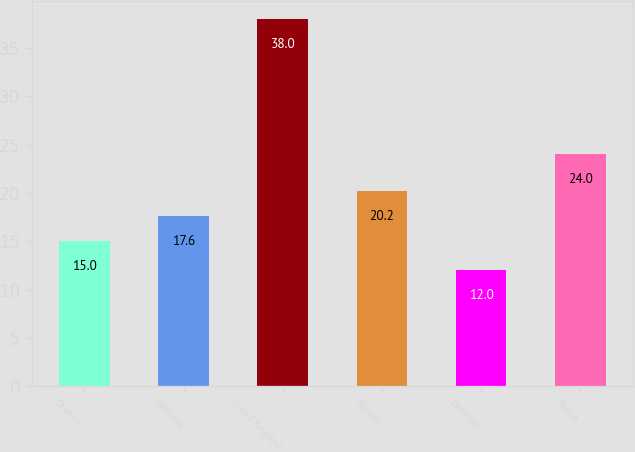<chart> <loc_0><loc_0><loc_500><loc_500><bar_chart><fcel>Onshore<fcel>Offshore<fcel>United Kingdom<fcel>Norway<fcel>Denmark<fcel>Russia<nl><fcel>15<fcel>17.6<fcel>38<fcel>20.2<fcel>12<fcel>24<nl></chart> 